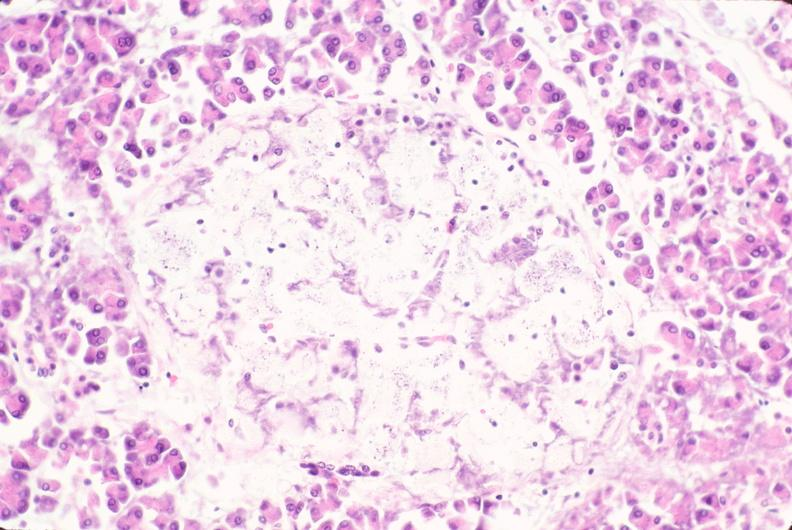does this image show pancreas, islet hyalinization, diabetes mellitus?
Answer the question using a single word or phrase. Yes 